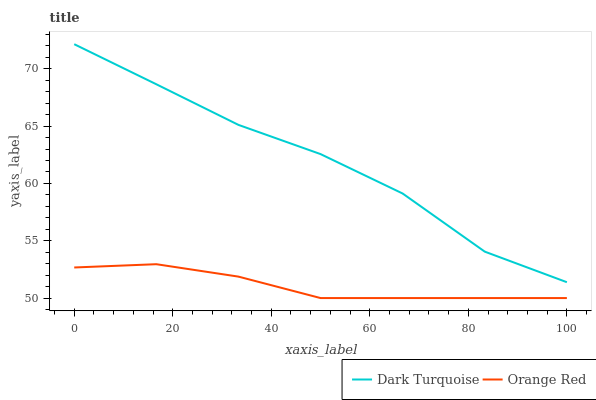Does Orange Red have the minimum area under the curve?
Answer yes or no. Yes. Does Dark Turquoise have the maximum area under the curve?
Answer yes or no. Yes. Does Orange Red have the maximum area under the curve?
Answer yes or no. No. Is Orange Red the smoothest?
Answer yes or no. Yes. Is Dark Turquoise the roughest?
Answer yes or no. Yes. Is Orange Red the roughest?
Answer yes or no. No. Does Orange Red have the lowest value?
Answer yes or no. Yes. Does Dark Turquoise have the highest value?
Answer yes or no. Yes. Does Orange Red have the highest value?
Answer yes or no. No. Is Orange Red less than Dark Turquoise?
Answer yes or no. Yes. Is Dark Turquoise greater than Orange Red?
Answer yes or no. Yes. Does Orange Red intersect Dark Turquoise?
Answer yes or no. No. 